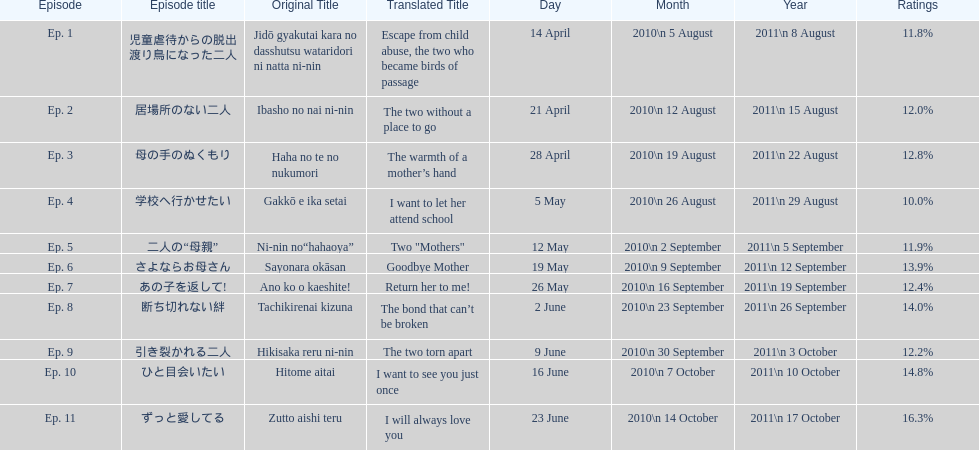What as the percentage total of ratings for episode 8? 14.0%. 